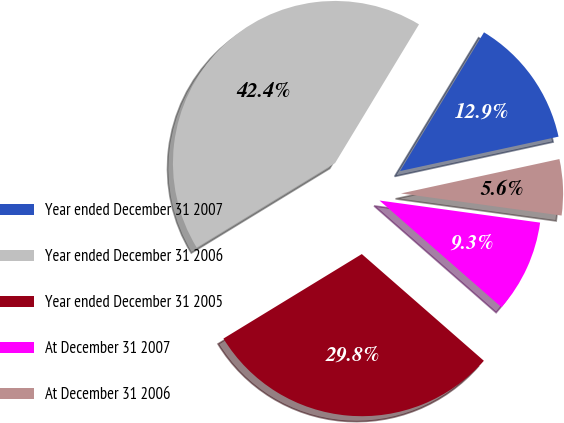<chart> <loc_0><loc_0><loc_500><loc_500><pie_chart><fcel>Year ended December 31 2007<fcel>Year ended December 31 2006<fcel>Year ended December 31 2005<fcel>At December 31 2007<fcel>At December 31 2006<nl><fcel>12.94%<fcel>42.39%<fcel>29.84%<fcel>9.26%<fcel>5.58%<nl></chart> 